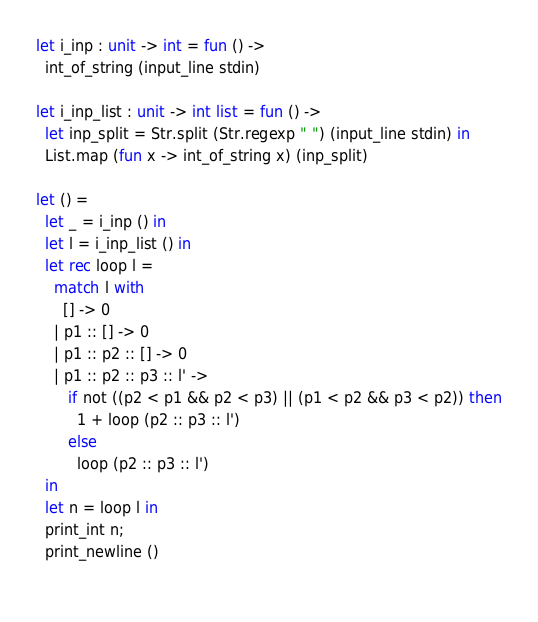<code> <loc_0><loc_0><loc_500><loc_500><_OCaml_>let i_inp : unit -> int = fun () ->
  int_of_string (input_line stdin)

let i_inp_list : unit -> int list = fun () ->
  let inp_split = Str.split (Str.regexp " ") (input_line stdin) in
  List.map (fun x -> int_of_string x) (inp_split)
  
let () =
  let _ = i_inp () in
  let l = i_inp_list () in
  let rec loop l =
    match l with
      [] -> 0
    | p1 :: [] -> 0
    | p1 :: p2 :: [] -> 0
    | p1 :: p2 :: p3 :: l' ->
       if not ((p2 < p1 && p2 < p3) || (p1 < p2 && p3 < p2)) then
         1 + loop (p2 :: p3 :: l')
       else
         loop (p2 :: p3 :: l')
  in
  let n = loop l in
  print_int n;
  print_newline ()
    
</code> 